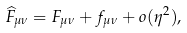<formula> <loc_0><loc_0><loc_500><loc_500>\widehat { F } _ { \mu \nu } = F _ { \mu \nu } + f _ { \mu \nu } + o ( \eta ^ { 2 } ) ,</formula> 